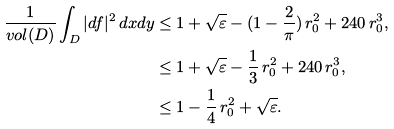Convert formula to latex. <formula><loc_0><loc_0><loc_500><loc_500>\frac { 1 } { v o l ( D ) } \int _ { D } | d f | ^ { 2 } \, d x d y & \leq 1 + \sqrt { \varepsilon } - ( 1 - \frac { 2 } { \pi } ) \, r _ { 0 } ^ { 2 } + 2 4 0 \, r _ { 0 } ^ { 3 } , \\ & \leq 1 + \sqrt { \varepsilon } - \frac { 1 } { 3 } \, r _ { 0 } ^ { 2 } + 2 4 0 \, r _ { 0 } ^ { 3 } , \\ & \leq 1 - \frac { 1 } { 4 } \, r _ { 0 } ^ { 2 } + \sqrt { \varepsilon } .</formula> 